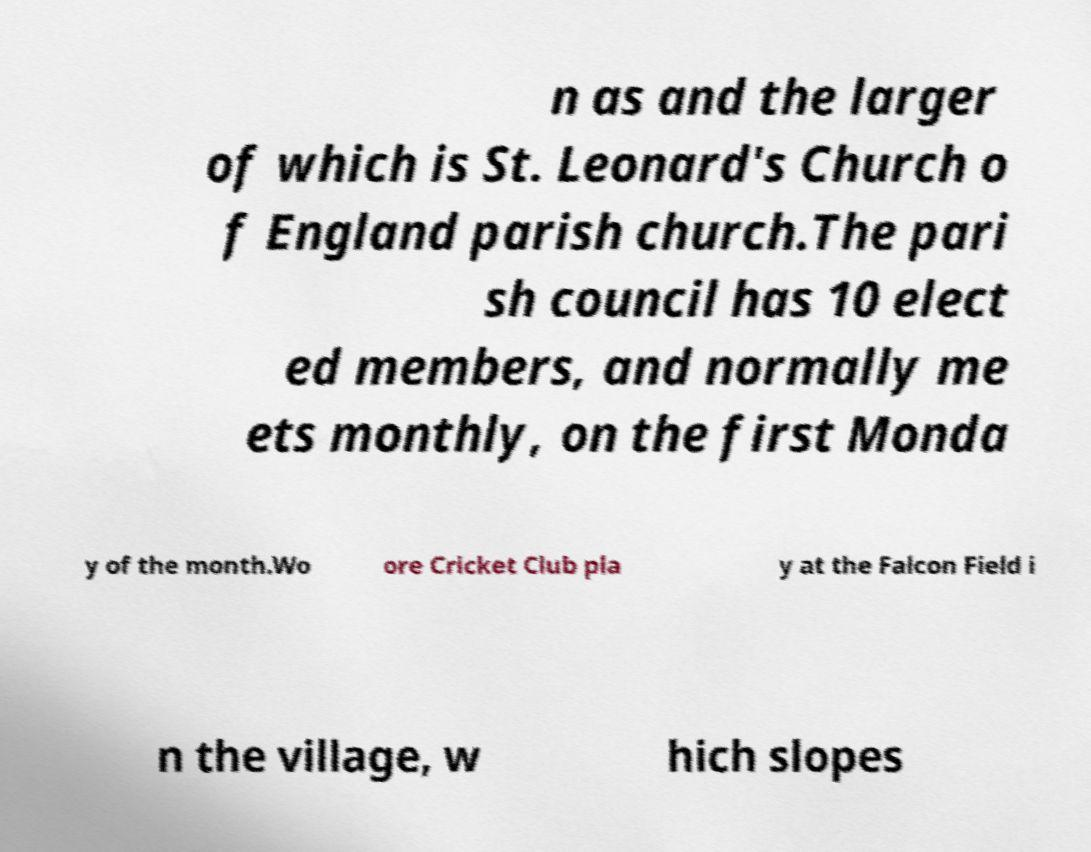Could you assist in decoding the text presented in this image and type it out clearly? n as and the larger of which is St. Leonard's Church o f England parish church.The pari sh council has 10 elect ed members, and normally me ets monthly, on the first Monda y of the month.Wo ore Cricket Club pla y at the Falcon Field i n the village, w hich slopes 